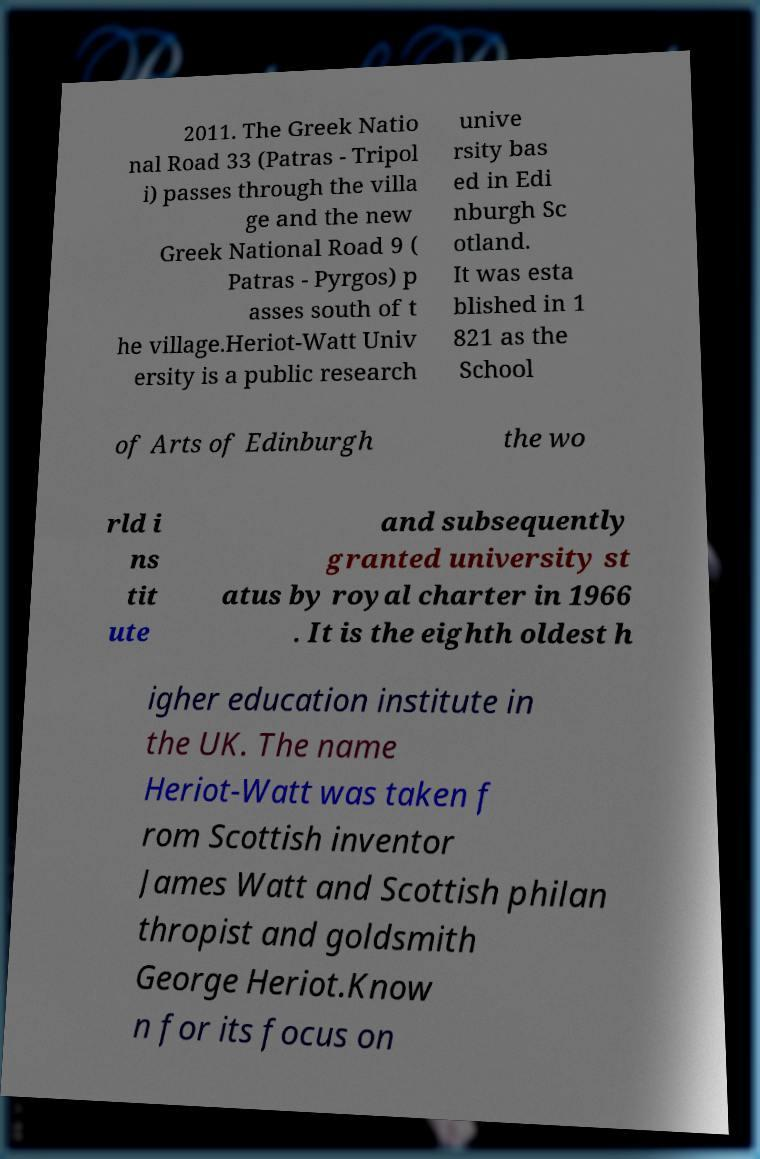I need the written content from this picture converted into text. Can you do that? 2011. The Greek Natio nal Road 33 (Patras - Tripol i) passes through the villa ge and the new Greek National Road 9 ( Patras - Pyrgos) p asses south of t he village.Heriot-Watt Univ ersity is a public research unive rsity bas ed in Edi nburgh Sc otland. It was esta blished in 1 821 as the School of Arts of Edinburgh the wo rld i ns tit ute and subsequently granted university st atus by royal charter in 1966 . It is the eighth oldest h igher education institute in the UK. The name Heriot-Watt was taken f rom Scottish inventor James Watt and Scottish philan thropist and goldsmith George Heriot.Know n for its focus on 